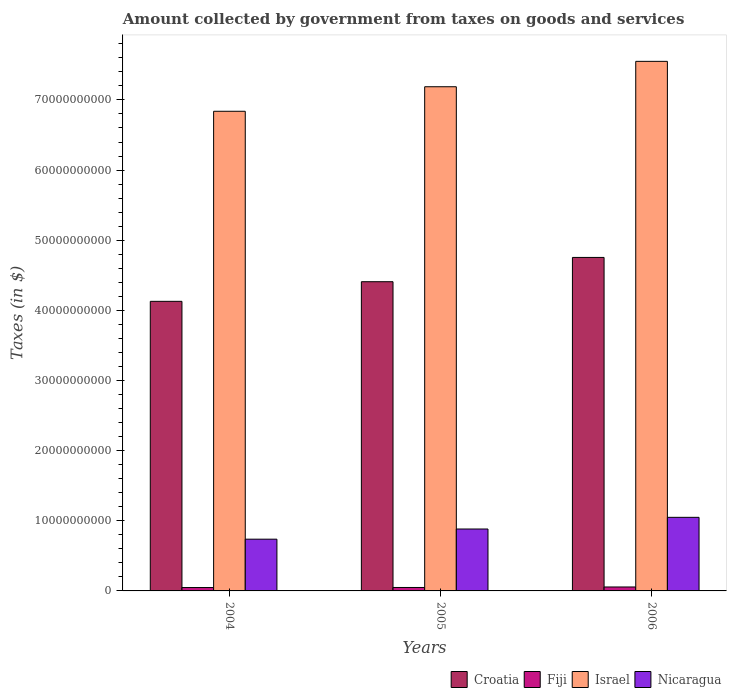How many groups of bars are there?
Ensure brevity in your answer.  3. How many bars are there on the 2nd tick from the left?
Ensure brevity in your answer.  4. In how many cases, is the number of bars for a given year not equal to the number of legend labels?
Ensure brevity in your answer.  0. What is the amount collected by government from taxes on goods and services in Israel in 2004?
Offer a very short reply. 6.84e+1. Across all years, what is the maximum amount collected by government from taxes on goods and services in Nicaragua?
Make the answer very short. 1.05e+1. Across all years, what is the minimum amount collected by government from taxes on goods and services in Israel?
Your answer should be very brief. 6.84e+1. In which year was the amount collected by government from taxes on goods and services in Croatia maximum?
Give a very brief answer. 2006. In which year was the amount collected by government from taxes on goods and services in Croatia minimum?
Your answer should be compact. 2004. What is the total amount collected by government from taxes on goods and services in Nicaragua in the graph?
Provide a succinct answer. 2.67e+1. What is the difference between the amount collected by government from taxes on goods and services in Israel in 2005 and that in 2006?
Your response must be concise. -3.62e+09. What is the difference between the amount collected by government from taxes on goods and services in Fiji in 2005 and the amount collected by government from taxes on goods and services in Croatia in 2006?
Your answer should be very brief. -4.71e+1. What is the average amount collected by government from taxes on goods and services in Fiji per year?
Provide a short and direct response. 5.12e+08. In the year 2005, what is the difference between the amount collected by government from taxes on goods and services in Nicaragua and amount collected by government from taxes on goods and services in Croatia?
Your response must be concise. -3.53e+1. What is the ratio of the amount collected by government from taxes on goods and services in Nicaragua in 2004 to that in 2006?
Make the answer very short. 0.7. Is the difference between the amount collected by government from taxes on goods and services in Nicaragua in 2004 and 2006 greater than the difference between the amount collected by government from taxes on goods and services in Croatia in 2004 and 2006?
Your answer should be very brief. Yes. What is the difference between the highest and the second highest amount collected by government from taxes on goods and services in Nicaragua?
Your answer should be very brief. 1.66e+09. What is the difference between the highest and the lowest amount collected by government from taxes on goods and services in Fiji?
Offer a terse response. 7.89e+07. Is the sum of the amount collected by government from taxes on goods and services in Nicaragua in 2004 and 2005 greater than the maximum amount collected by government from taxes on goods and services in Israel across all years?
Give a very brief answer. No. Is it the case that in every year, the sum of the amount collected by government from taxes on goods and services in Nicaragua and amount collected by government from taxes on goods and services in Fiji is greater than the sum of amount collected by government from taxes on goods and services in Croatia and amount collected by government from taxes on goods and services in Israel?
Your answer should be very brief. No. What does the 3rd bar from the left in 2006 represents?
Give a very brief answer. Israel. What does the 2nd bar from the right in 2004 represents?
Your response must be concise. Israel. Is it the case that in every year, the sum of the amount collected by government from taxes on goods and services in Fiji and amount collected by government from taxes on goods and services in Croatia is greater than the amount collected by government from taxes on goods and services in Nicaragua?
Offer a terse response. Yes. How many bars are there?
Provide a short and direct response. 12. What is the difference between two consecutive major ticks on the Y-axis?
Offer a terse response. 1.00e+1. Does the graph contain any zero values?
Your answer should be compact. No. Where does the legend appear in the graph?
Your answer should be very brief. Bottom right. How are the legend labels stacked?
Keep it short and to the point. Horizontal. What is the title of the graph?
Your answer should be very brief. Amount collected by government from taxes on goods and services. What is the label or title of the Y-axis?
Keep it short and to the point. Taxes (in $). What is the Taxes (in $) in Croatia in 2004?
Ensure brevity in your answer.  4.13e+1. What is the Taxes (in $) in Fiji in 2004?
Offer a terse response. 4.83e+08. What is the Taxes (in $) in Israel in 2004?
Keep it short and to the point. 6.84e+1. What is the Taxes (in $) of Nicaragua in 2004?
Keep it short and to the point. 7.38e+09. What is the Taxes (in $) in Croatia in 2005?
Your response must be concise. 4.41e+1. What is the Taxes (in $) in Fiji in 2005?
Give a very brief answer. 4.91e+08. What is the Taxes (in $) of Israel in 2005?
Keep it short and to the point. 7.19e+1. What is the Taxes (in $) of Nicaragua in 2005?
Offer a very short reply. 8.83e+09. What is the Taxes (in $) in Croatia in 2006?
Your answer should be compact. 4.75e+1. What is the Taxes (in $) in Fiji in 2006?
Give a very brief answer. 5.62e+08. What is the Taxes (in $) of Israel in 2006?
Ensure brevity in your answer.  7.55e+1. What is the Taxes (in $) in Nicaragua in 2006?
Make the answer very short. 1.05e+1. Across all years, what is the maximum Taxes (in $) of Croatia?
Offer a very short reply. 4.75e+1. Across all years, what is the maximum Taxes (in $) of Fiji?
Your response must be concise. 5.62e+08. Across all years, what is the maximum Taxes (in $) in Israel?
Provide a short and direct response. 7.55e+1. Across all years, what is the maximum Taxes (in $) in Nicaragua?
Provide a short and direct response. 1.05e+1. Across all years, what is the minimum Taxes (in $) in Croatia?
Your answer should be compact. 4.13e+1. Across all years, what is the minimum Taxes (in $) in Fiji?
Give a very brief answer. 4.83e+08. Across all years, what is the minimum Taxes (in $) of Israel?
Offer a terse response. 6.84e+1. Across all years, what is the minimum Taxes (in $) of Nicaragua?
Provide a short and direct response. 7.38e+09. What is the total Taxes (in $) of Croatia in the graph?
Your response must be concise. 1.33e+11. What is the total Taxes (in $) of Fiji in the graph?
Offer a very short reply. 1.54e+09. What is the total Taxes (in $) in Israel in the graph?
Provide a succinct answer. 2.16e+11. What is the total Taxes (in $) of Nicaragua in the graph?
Make the answer very short. 2.67e+1. What is the difference between the Taxes (in $) of Croatia in 2004 and that in 2005?
Make the answer very short. -2.80e+09. What is the difference between the Taxes (in $) in Fiji in 2004 and that in 2005?
Provide a succinct answer. -8.84e+06. What is the difference between the Taxes (in $) in Israel in 2004 and that in 2005?
Offer a very short reply. -3.50e+09. What is the difference between the Taxes (in $) in Nicaragua in 2004 and that in 2005?
Give a very brief answer. -1.45e+09. What is the difference between the Taxes (in $) in Croatia in 2004 and that in 2006?
Ensure brevity in your answer.  -6.26e+09. What is the difference between the Taxes (in $) in Fiji in 2004 and that in 2006?
Provide a short and direct response. -7.89e+07. What is the difference between the Taxes (in $) of Israel in 2004 and that in 2006?
Make the answer very short. -7.12e+09. What is the difference between the Taxes (in $) in Nicaragua in 2004 and that in 2006?
Make the answer very short. -3.11e+09. What is the difference between the Taxes (in $) of Croatia in 2005 and that in 2006?
Provide a succinct answer. -3.46e+09. What is the difference between the Taxes (in $) in Fiji in 2005 and that in 2006?
Give a very brief answer. -7.00e+07. What is the difference between the Taxes (in $) of Israel in 2005 and that in 2006?
Keep it short and to the point. -3.62e+09. What is the difference between the Taxes (in $) of Nicaragua in 2005 and that in 2006?
Your answer should be very brief. -1.66e+09. What is the difference between the Taxes (in $) of Croatia in 2004 and the Taxes (in $) of Fiji in 2005?
Offer a terse response. 4.08e+1. What is the difference between the Taxes (in $) of Croatia in 2004 and the Taxes (in $) of Israel in 2005?
Your answer should be very brief. -3.06e+1. What is the difference between the Taxes (in $) of Croatia in 2004 and the Taxes (in $) of Nicaragua in 2005?
Keep it short and to the point. 3.25e+1. What is the difference between the Taxes (in $) of Fiji in 2004 and the Taxes (in $) of Israel in 2005?
Offer a terse response. -7.14e+1. What is the difference between the Taxes (in $) of Fiji in 2004 and the Taxes (in $) of Nicaragua in 2005?
Your response must be concise. -8.34e+09. What is the difference between the Taxes (in $) of Israel in 2004 and the Taxes (in $) of Nicaragua in 2005?
Keep it short and to the point. 5.96e+1. What is the difference between the Taxes (in $) in Croatia in 2004 and the Taxes (in $) in Fiji in 2006?
Give a very brief answer. 4.07e+1. What is the difference between the Taxes (in $) of Croatia in 2004 and the Taxes (in $) of Israel in 2006?
Offer a terse response. -3.42e+1. What is the difference between the Taxes (in $) of Croatia in 2004 and the Taxes (in $) of Nicaragua in 2006?
Give a very brief answer. 3.08e+1. What is the difference between the Taxes (in $) of Fiji in 2004 and the Taxes (in $) of Israel in 2006?
Ensure brevity in your answer.  -7.50e+1. What is the difference between the Taxes (in $) of Fiji in 2004 and the Taxes (in $) of Nicaragua in 2006?
Provide a short and direct response. -1.00e+1. What is the difference between the Taxes (in $) of Israel in 2004 and the Taxes (in $) of Nicaragua in 2006?
Your answer should be very brief. 5.79e+1. What is the difference between the Taxes (in $) of Croatia in 2005 and the Taxes (in $) of Fiji in 2006?
Keep it short and to the point. 4.35e+1. What is the difference between the Taxes (in $) of Croatia in 2005 and the Taxes (in $) of Israel in 2006?
Offer a very short reply. -3.14e+1. What is the difference between the Taxes (in $) in Croatia in 2005 and the Taxes (in $) in Nicaragua in 2006?
Your response must be concise. 3.36e+1. What is the difference between the Taxes (in $) of Fiji in 2005 and the Taxes (in $) of Israel in 2006?
Offer a very short reply. -7.50e+1. What is the difference between the Taxes (in $) in Fiji in 2005 and the Taxes (in $) in Nicaragua in 2006?
Keep it short and to the point. -1.00e+1. What is the difference between the Taxes (in $) in Israel in 2005 and the Taxes (in $) in Nicaragua in 2006?
Your answer should be compact. 6.14e+1. What is the average Taxes (in $) of Croatia per year?
Offer a terse response. 4.43e+1. What is the average Taxes (in $) in Fiji per year?
Offer a terse response. 5.12e+08. What is the average Taxes (in $) of Israel per year?
Keep it short and to the point. 7.19e+1. What is the average Taxes (in $) in Nicaragua per year?
Make the answer very short. 8.90e+09. In the year 2004, what is the difference between the Taxes (in $) of Croatia and Taxes (in $) of Fiji?
Your answer should be compact. 4.08e+1. In the year 2004, what is the difference between the Taxes (in $) of Croatia and Taxes (in $) of Israel?
Provide a short and direct response. -2.71e+1. In the year 2004, what is the difference between the Taxes (in $) in Croatia and Taxes (in $) in Nicaragua?
Your response must be concise. 3.39e+1. In the year 2004, what is the difference between the Taxes (in $) in Fiji and Taxes (in $) in Israel?
Your answer should be very brief. -6.79e+1. In the year 2004, what is the difference between the Taxes (in $) of Fiji and Taxes (in $) of Nicaragua?
Your answer should be compact. -6.89e+09. In the year 2004, what is the difference between the Taxes (in $) of Israel and Taxes (in $) of Nicaragua?
Your response must be concise. 6.10e+1. In the year 2005, what is the difference between the Taxes (in $) in Croatia and Taxes (in $) in Fiji?
Keep it short and to the point. 4.36e+1. In the year 2005, what is the difference between the Taxes (in $) of Croatia and Taxes (in $) of Israel?
Make the answer very short. -2.78e+1. In the year 2005, what is the difference between the Taxes (in $) of Croatia and Taxes (in $) of Nicaragua?
Provide a succinct answer. 3.53e+1. In the year 2005, what is the difference between the Taxes (in $) in Fiji and Taxes (in $) in Israel?
Make the answer very short. -7.14e+1. In the year 2005, what is the difference between the Taxes (in $) of Fiji and Taxes (in $) of Nicaragua?
Ensure brevity in your answer.  -8.33e+09. In the year 2005, what is the difference between the Taxes (in $) of Israel and Taxes (in $) of Nicaragua?
Make the answer very short. 6.31e+1. In the year 2006, what is the difference between the Taxes (in $) of Croatia and Taxes (in $) of Fiji?
Provide a succinct answer. 4.70e+1. In the year 2006, what is the difference between the Taxes (in $) of Croatia and Taxes (in $) of Israel?
Give a very brief answer. -2.80e+1. In the year 2006, what is the difference between the Taxes (in $) of Croatia and Taxes (in $) of Nicaragua?
Offer a very short reply. 3.71e+1. In the year 2006, what is the difference between the Taxes (in $) of Fiji and Taxes (in $) of Israel?
Keep it short and to the point. -7.49e+1. In the year 2006, what is the difference between the Taxes (in $) in Fiji and Taxes (in $) in Nicaragua?
Offer a very short reply. -9.93e+09. In the year 2006, what is the difference between the Taxes (in $) in Israel and Taxes (in $) in Nicaragua?
Your answer should be very brief. 6.50e+1. What is the ratio of the Taxes (in $) in Croatia in 2004 to that in 2005?
Make the answer very short. 0.94. What is the ratio of the Taxes (in $) in Fiji in 2004 to that in 2005?
Ensure brevity in your answer.  0.98. What is the ratio of the Taxes (in $) of Israel in 2004 to that in 2005?
Provide a short and direct response. 0.95. What is the ratio of the Taxes (in $) of Nicaragua in 2004 to that in 2005?
Ensure brevity in your answer.  0.84. What is the ratio of the Taxes (in $) in Croatia in 2004 to that in 2006?
Your answer should be very brief. 0.87. What is the ratio of the Taxes (in $) of Fiji in 2004 to that in 2006?
Offer a very short reply. 0.86. What is the ratio of the Taxes (in $) of Israel in 2004 to that in 2006?
Offer a terse response. 0.91. What is the ratio of the Taxes (in $) of Nicaragua in 2004 to that in 2006?
Keep it short and to the point. 0.7. What is the ratio of the Taxes (in $) of Croatia in 2005 to that in 2006?
Make the answer very short. 0.93. What is the ratio of the Taxes (in $) in Fiji in 2005 to that in 2006?
Your response must be concise. 0.88. What is the ratio of the Taxes (in $) of Israel in 2005 to that in 2006?
Provide a succinct answer. 0.95. What is the ratio of the Taxes (in $) of Nicaragua in 2005 to that in 2006?
Offer a very short reply. 0.84. What is the difference between the highest and the second highest Taxes (in $) in Croatia?
Your answer should be very brief. 3.46e+09. What is the difference between the highest and the second highest Taxes (in $) of Fiji?
Offer a terse response. 7.00e+07. What is the difference between the highest and the second highest Taxes (in $) in Israel?
Your answer should be compact. 3.62e+09. What is the difference between the highest and the second highest Taxes (in $) of Nicaragua?
Provide a succinct answer. 1.66e+09. What is the difference between the highest and the lowest Taxes (in $) of Croatia?
Your answer should be compact. 6.26e+09. What is the difference between the highest and the lowest Taxes (in $) in Fiji?
Offer a terse response. 7.89e+07. What is the difference between the highest and the lowest Taxes (in $) of Israel?
Offer a terse response. 7.12e+09. What is the difference between the highest and the lowest Taxes (in $) of Nicaragua?
Keep it short and to the point. 3.11e+09. 